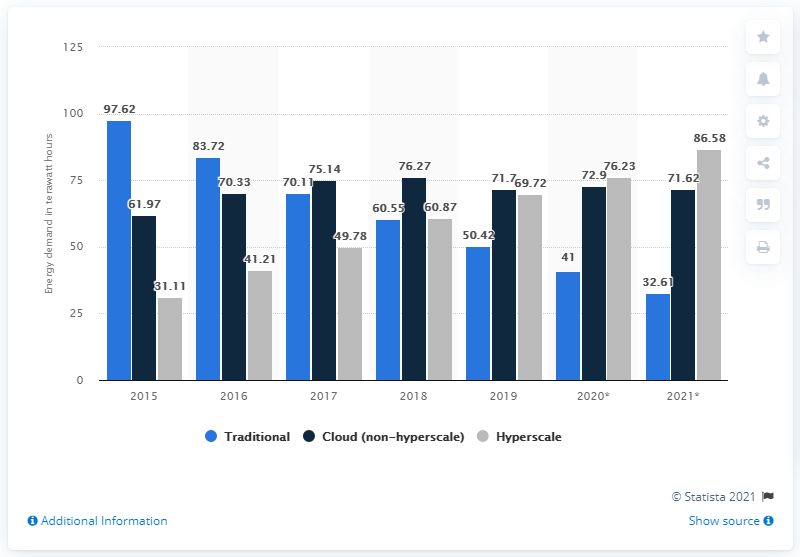List a handful of essential elements in this visual. The sum of the first and last bar in the chart is 184.2. The year with the highest number in hyperscale is 2021. 